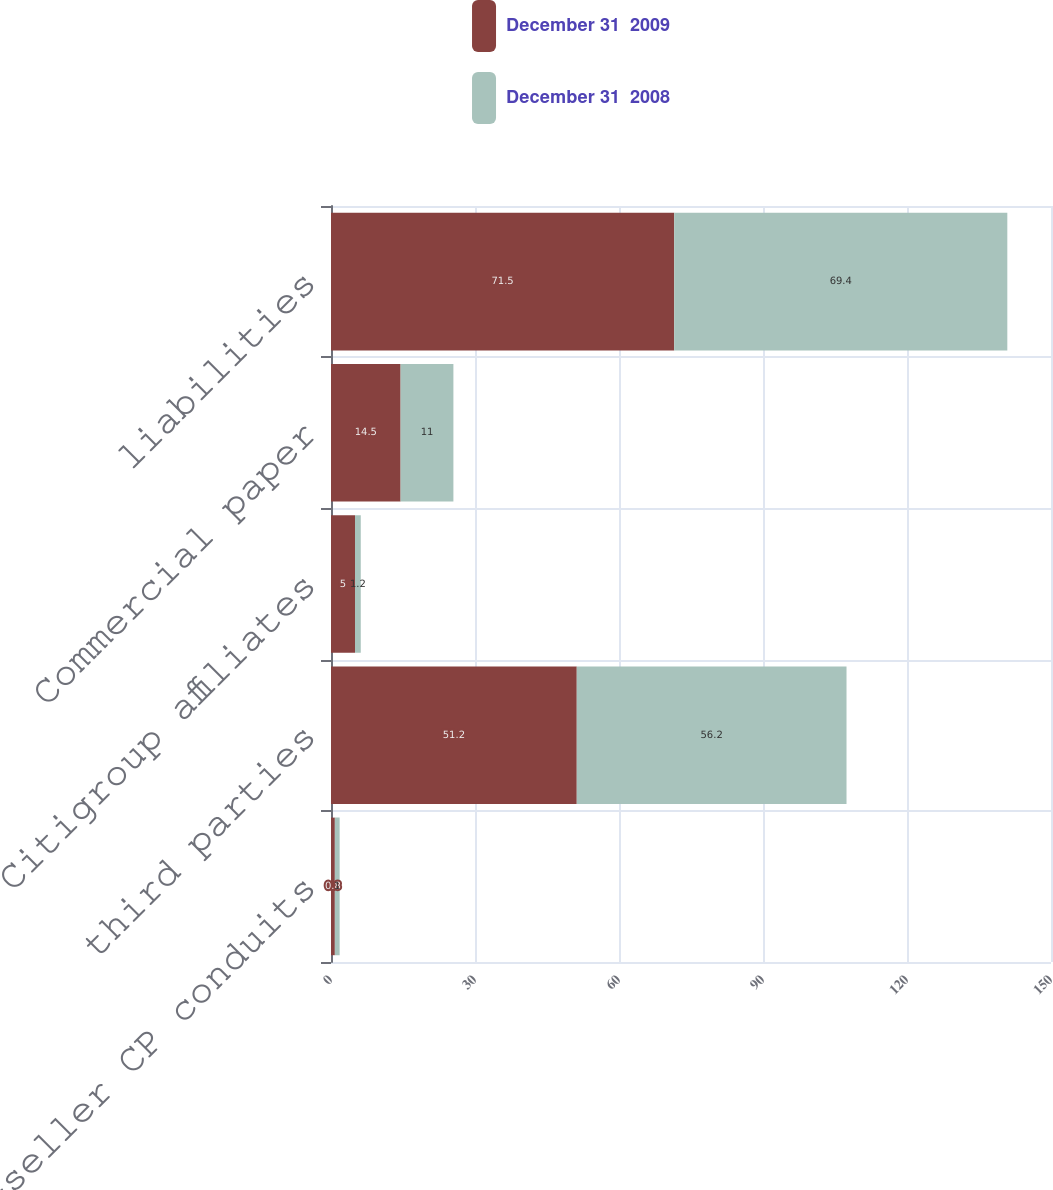Convert chart to OTSL. <chart><loc_0><loc_0><loc_500><loc_500><stacked_bar_chart><ecel><fcel>multi-seller CP conduits<fcel>third parties<fcel>Citigroup affiliates<fcel>Commercial paper<fcel>liabilities<nl><fcel>December 31  2009<fcel>0.8<fcel>51.2<fcel>5<fcel>14.5<fcel>71.5<nl><fcel>December 31  2008<fcel>1<fcel>56.2<fcel>1.2<fcel>11<fcel>69.4<nl></chart> 